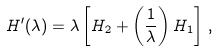<formula> <loc_0><loc_0><loc_500><loc_500>H ^ { \prime } ( \lambda ) = \lambda \left [ H _ { 2 } + \left ( \frac { 1 } { \lambda } \right ) H _ { 1 } \right ] \, ,</formula> 